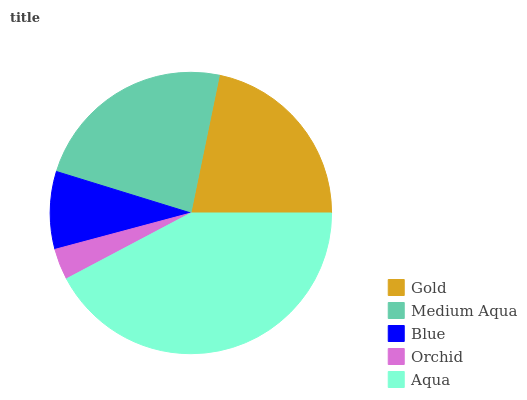Is Orchid the minimum?
Answer yes or no. Yes. Is Aqua the maximum?
Answer yes or no. Yes. Is Medium Aqua the minimum?
Answer yes or no. No. Is Medium Aqua the maximum?
Answer yes or no. No. Is Medium Aqua greater than Gold?
Answer yes or no. Yes. Is Gold less than Medium Aqua?
Answer yes or no. Yes. Is Gold greater than Medium Aqua?
Answer yes or no. No. Is Medium Aqua less than Gold?
Answer yes or no. No. Is Gold the high median?
Answer yes or no. Yes. Is Gold the low median?
Answer yes or no. Yes. Is Aqua the high median?
Answer yes or no. No. Is Aqua the low median?
Answer yes or no. No. 